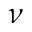Convert formula to latex. <formula><loc_0><loc_0><loc_500><loc_500>\nu</formula> 